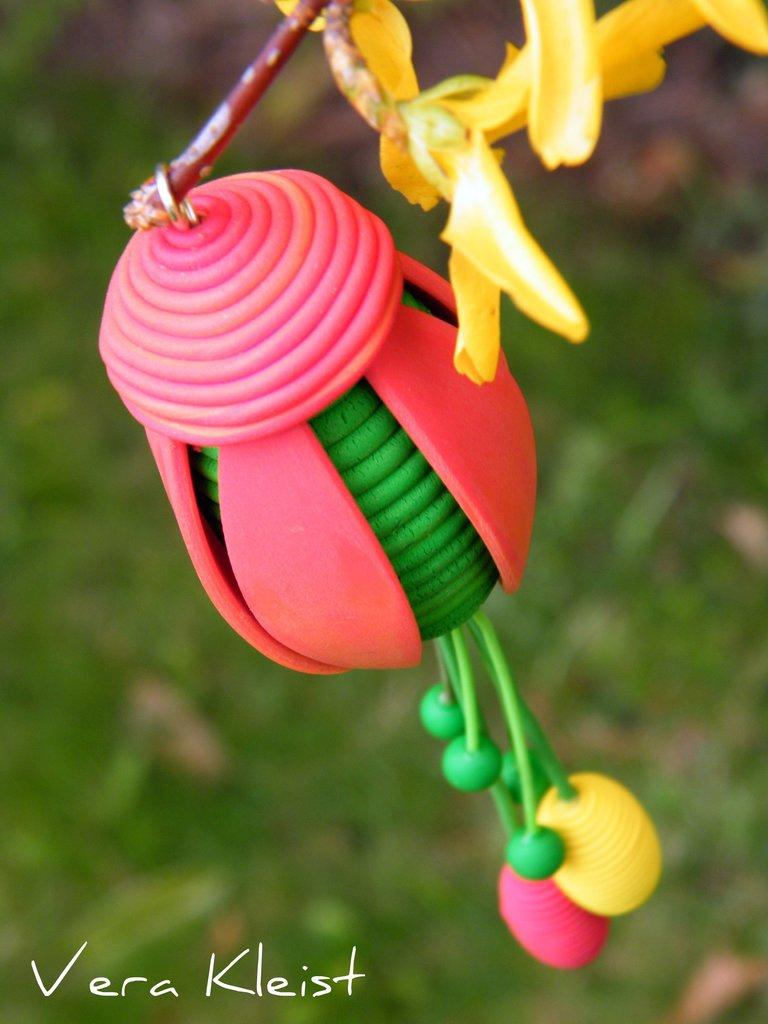What colors are used for the objects in the image? The objects in the image are in pink and green colors. What type of flowers can be seen in the image? There are flowers in yellow color in the image. What is the color of the background in the image? The background of the image is green. What type of crime is being committed in the image? There is no crime being committed in the image; it features objects and flowers in various colors. What does the fork have to do with the image? There is no fork present in the image. 